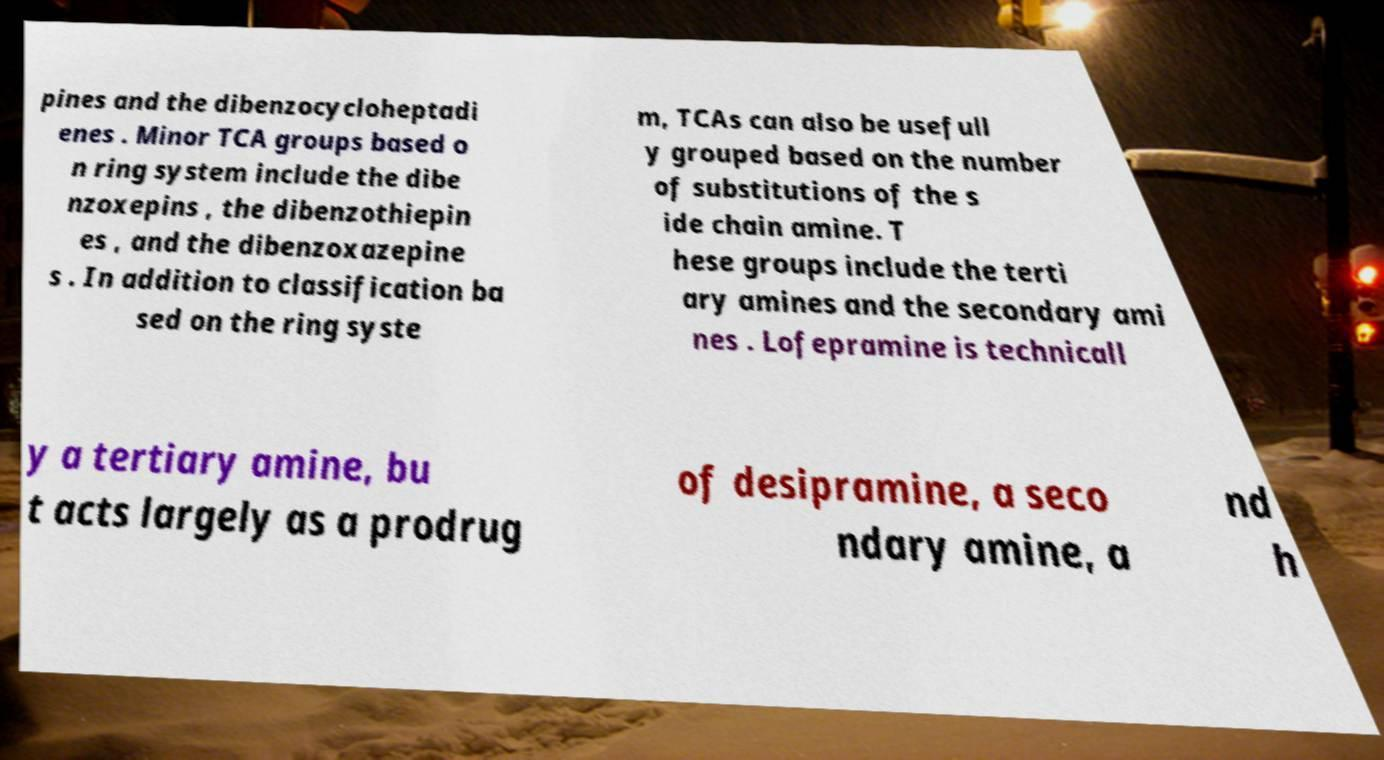Please read and relay the text visible in this image. What does it say? pines and the dibenzocycloheptadi enes . Minor TCA groups based o n ring system include the dibe nzoxepins , the dibenzothiepin es , and the dibenzoxazepine s . In addition to classification ba sed on the ring syste m, TCAs can also be usefull y grouped based on the number of substitutions of the s ide chain amine. T hese groups include the terti ary amines and the secondary ami nes . Lofepramine is technicall y a tertiary amine, bu t acts largely as a prodrug of desipramine, a seco ndary amine, a nd h 